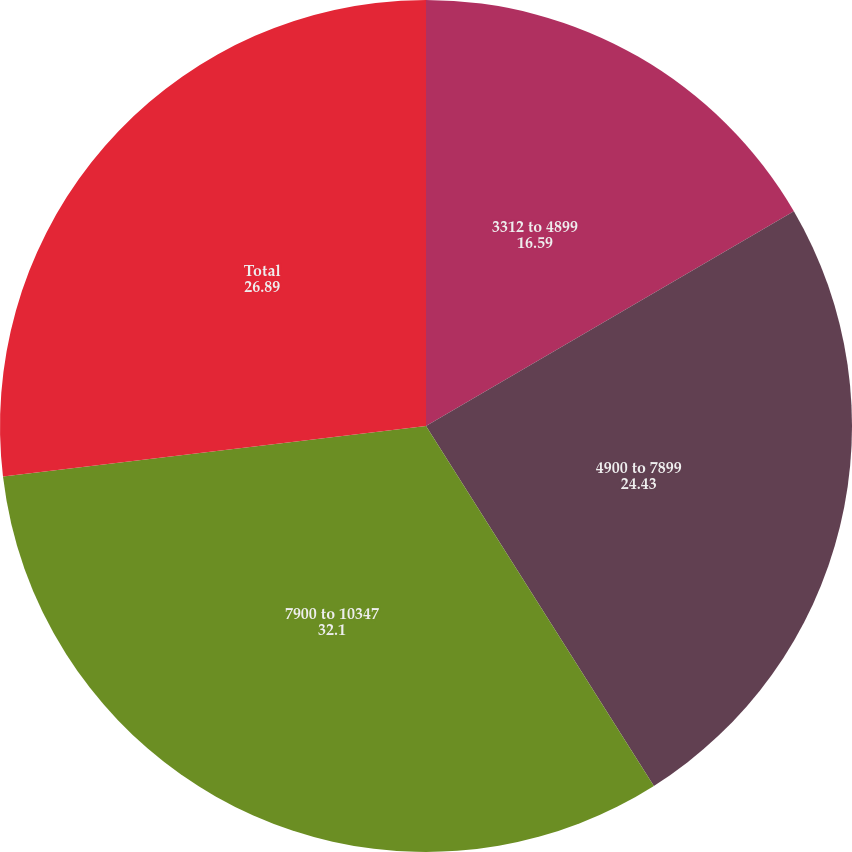Convert chart. <chart><loc_0><loc_0><loc_500><loc_500><pie_chart><fcel>3312 to 4899<fcel>4900 to 7899<fcel>7900 to 10347<fcel>Total<nl><fcel>16.59%<fcel>24.43%<fcel>32.1%<fcel>26.89%<nl></chart> 